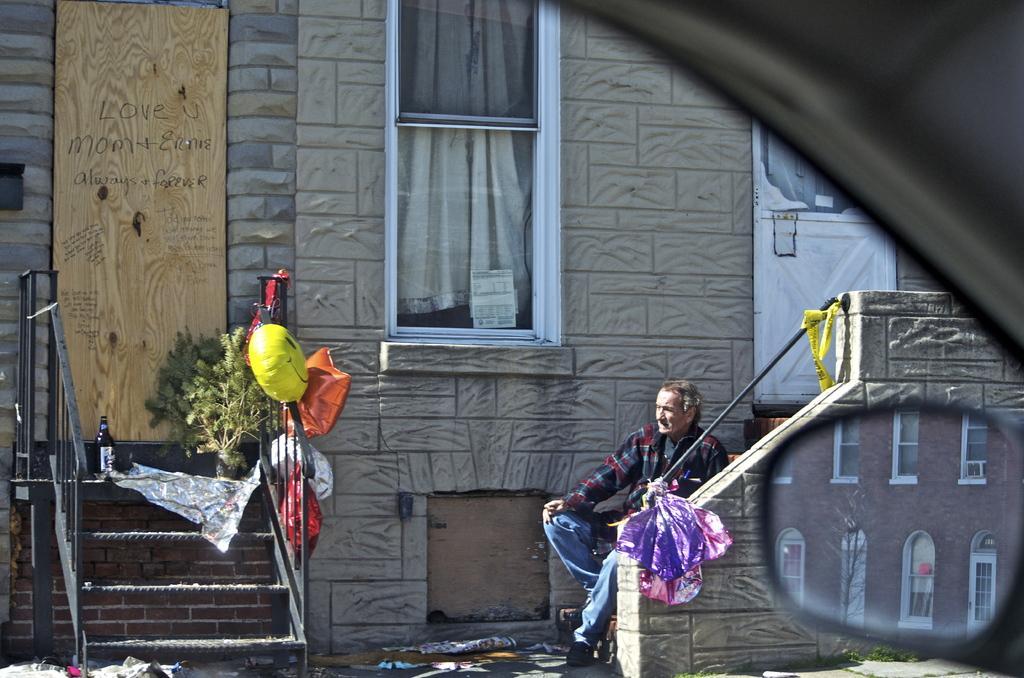In one or two sentences, can you explain what this image depicts? In this image I can see a building, window, a door, stairs, a plant, a yellow colour thing and few other things. Here I can see a man is sitting and I can also see a vehicle's mirror over here. 